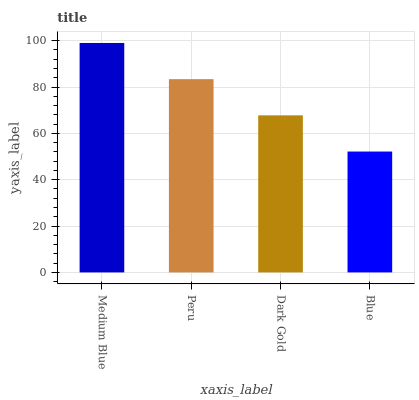Is Peru the minimum?
Answer yes or no. No. Is Peru the maximum?
Answer yes or no. No. Is Medium Blue greater than Peru?
Answer yes or no. Yes. Is Peru less than Medium Blue?
Answer yes or no. Yes. Is Peru greater than Medium Blue?
Answer yes or no. No. Is Medium Blue less than Peru?
Answer yes or no. No. Is Peru the high median?
Answer yes or no. Yes. Is Dark Gold the low median?
Answer yes or no. Yes. Is Medium Blue the high median?
Answer yes or no. No. Is Medium Blue the low median?
Answer yes or no. No. 